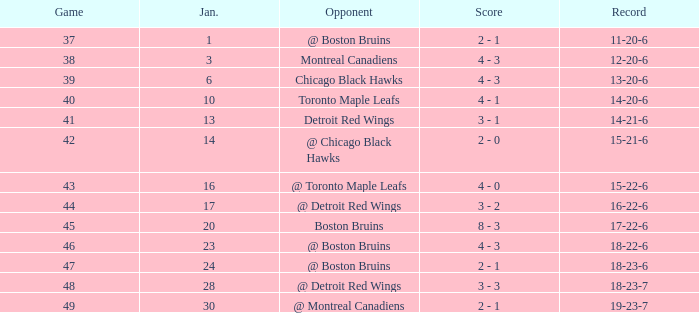What was the total number of games on January 20? 1.0. 